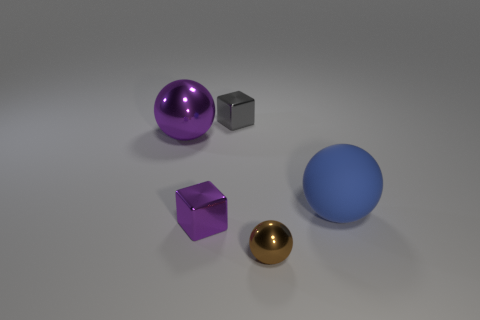How big is the block in front of the metal sphere that is behind the tiny metallic sphere in front of the purple block?
Keep it short and to the point. Small. There is a tiny purple shiny thing; are there any purple shiny things behind it?
Ensure brevity in your answer.  Yes. What shape is the other thing that is the same color as the big metallic thing?
Make the answer very short. Cube. How many objects are tiny cubes in front of the big matte sphere or metal objects?
Ensure brevity in your answer.  4. What size is the other purple ball that is the same material as the small ball?
Ensure brevity in your answer.  Large. Is the size of the brown metallic sphere the same as the block that is behind the purple metallic cube?
Your response must be concise. Yes. The ball that is right of the tiny gray shiny thing and behind the purple cube is what color?
Make the answer very short. Blue. How many objects are blocks behind the large blue matte thing or tiny metallic objects in front of the gray block?
Your answer should be very brief. 3. There is a metal sphere that is to the left of the small shiny object in front of the cube in front of the big metal thing; what is its color?
Offer a terse response. Purple. Is there a tiny purple metal object that has the same shape as the blue object?
Your response must be concise. No. 